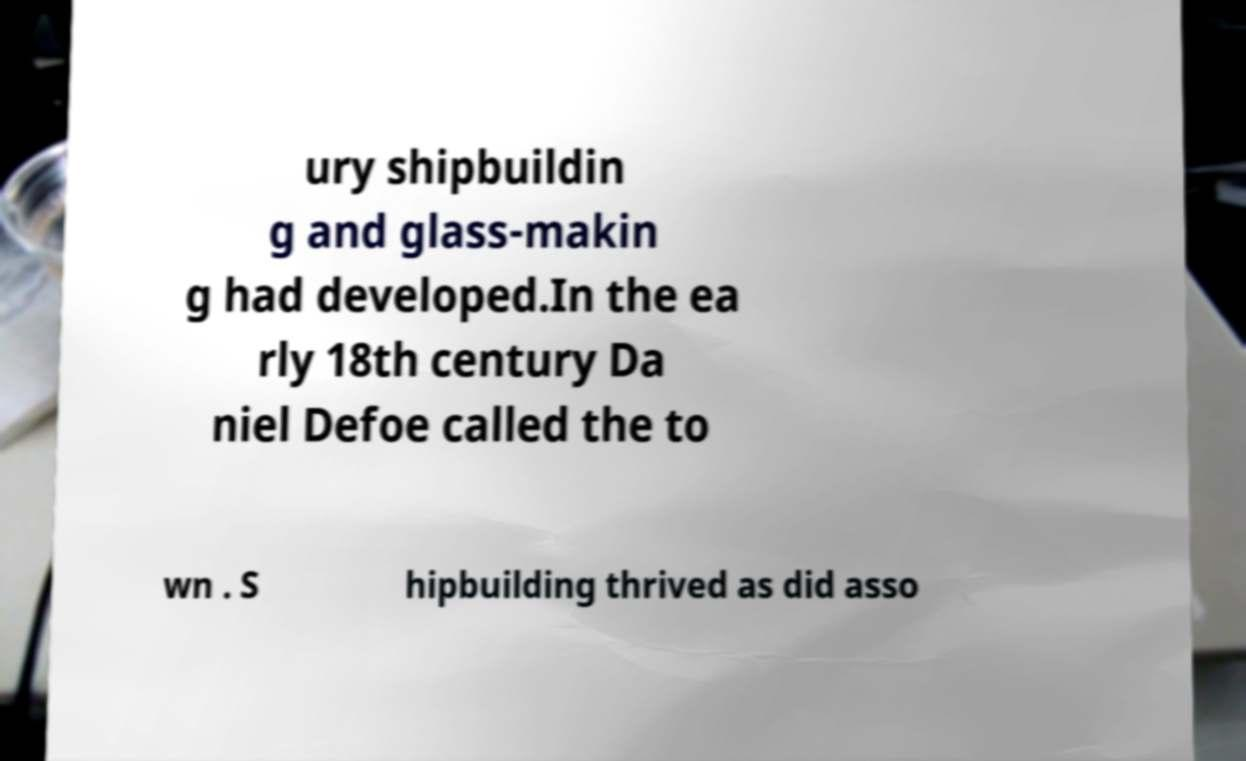There's text embedded in this image that I need extracted. Can you transcribe it verbatim? ury shipbuildin g and glass-makin g had developed.In the ea rly 18th century Da niel Defoe called the to wn . S hipbuilding thrived as did asso 